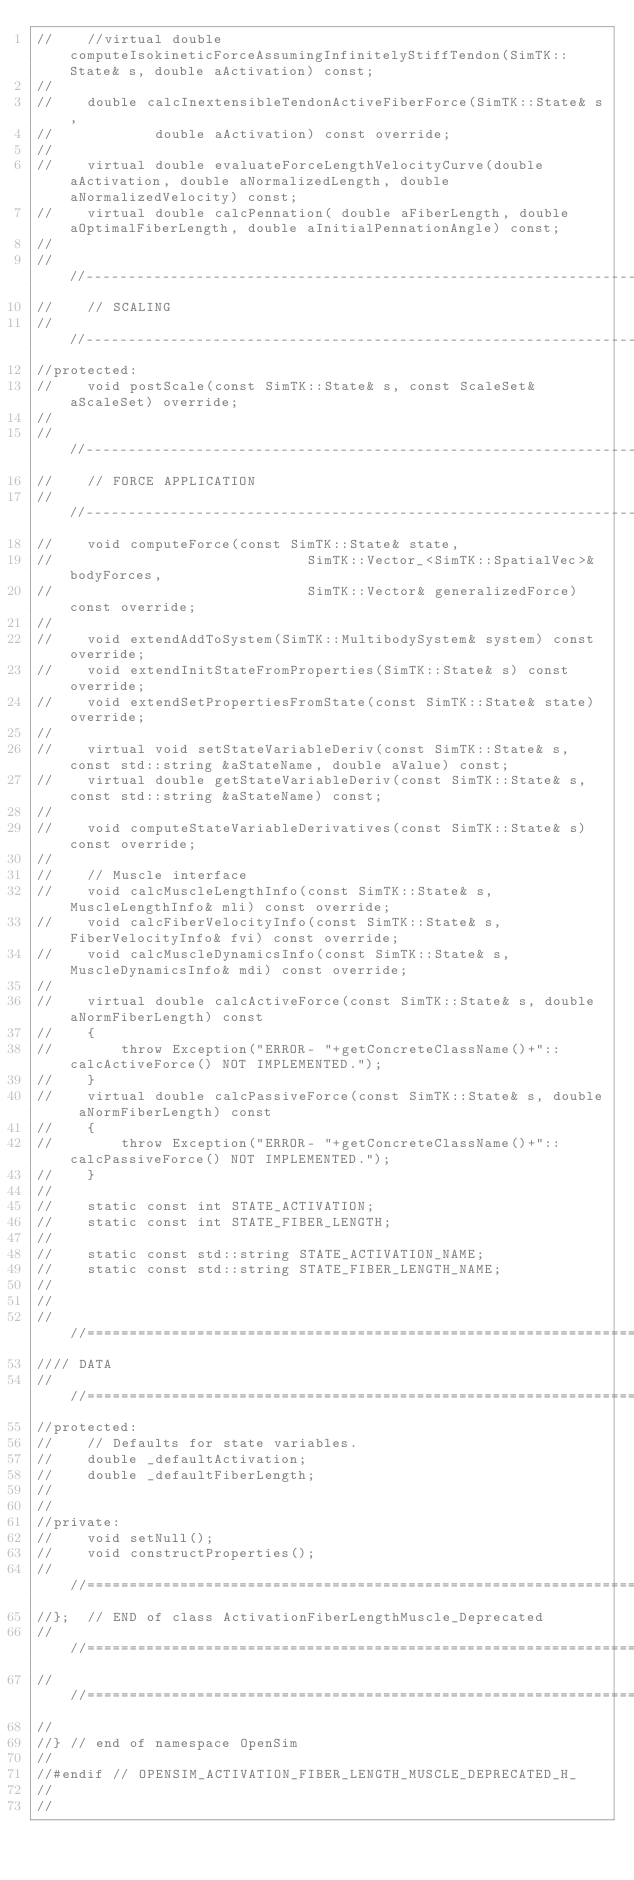Convert code to text. <code><loc_0><loc_0><loc_500><loc_500><_C_>//    //virtual double computeIsokineticForceAssumingInfinitelyStiffTendon(SimTK::State& s, double aActivation) const;
//    
//    double calcInextensibleTendonActiveFiberForce(SimTK::State& s, 
//            double aActivation) const override;
//
//    virtual double evaluateForceLengthVelocityCurve(double aActivation, double aNormalizedLength, double aNormalizedVelocity) const;
//    virtual double calcPennation( double aFiberLength, double aOptimalFiberLength, double aInitialPennationAngle) const;
// 
//    //--------------------------------------------------------------------------
//    // SCALING
//    //--------------------------------------------------------------------------
//protected:
//    void postScale(const SimTK::State& s, const ScaleSet& aScaleSet) override;
//
//    //--------------------------------------------------------------------------
//    // FORCE APPLICATION
//    //--------------------------------------------------------------------------
//    void computeForce(const SimTK::State& state, 
//                              SimTK::Vector_<SimTK::SpatialVec>& bodyForces, 
//                              SimTK::Vector& generalizedForce) const override;
//
//    void extendAddToSystem(SimTK::MultibodySystem& system) const override;
//    void extendInitStateFromProperties(SimTK::State& s) const override;
//    void extendSetPropertiesFromState(const SimTK::State& state) override;
//
//    virtual void setStateVariableDeriv(const SimTK::State& s, const std::string &aStateName, double aValue) const;
//    virtual double getStateVariableDeriv(const SimTK::State& s, const std::string &aStateName) const;
//
//    void computeStateVariableDerivatives(const SimTK::State& s) const override;
//
//    // Muscle interface
//    void calcMuscleLengthInfo(const SimTK::State& s, MuscleLengthInfo& mli) const override;
//    void calcFiberVelocityInfo(const SimTK::State& s, FiberVelocityInfo& fvi) const override;
//    void calcMuscleDynamicsInfo(const SimTK::State& s, MuscleDynamicsInfo& mdi) const override;
//
//    virtual double calcActiveForce(const SimTK::State& s, double aNormFiberLength) const
//    {
//        throw Exception("ERROR- "+getConcreteClassName()+"::calcActiveForce() NOT IMPLEMENTED.");
//    }
//    virtual double calcPassiveForce(const SimTK::State& s, double aNormFiberLength) const
//    {
//        throw Exception("ERROR- "+getConcreteClassName()+"::calcPassiveForce() NOT IMPLEMENTED.");
//    }
//
//    static const int STATE_ACTIVATION;
//    static const int STATE_FIBER_LENGTH;
//
//    static const std::string STATE_ACTIVATION_NAME;
//    static const std::string STATE_FIBER_LENGTH_NAME;
//
//
////==============================================================================
//// DATA
////==============================================================================
//protected:
//    // Defaults for state variables.
//    double _defaultActivation;
//    double _defaultFiberLength;
//
//
//private:
//    void setNull();
//    void constructProperties();
////==============================================================================
//};  // END of class ActivationFiberLengthMuscle_Deprecated
////==============================================================================
////==============================================================================
//
//} // end of namespace OpenSim
//
//#endif // OPENSIM_ACTIVATION_FIBER_LENGTH_MUSCLE_DEPRECATED_H_
//
//
</code> 